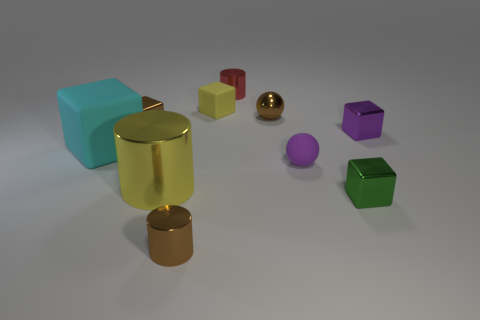Is there a tiny rubber object that is in front of the tiny brown metallic object left of the large yellow metal cylinder?
Offer a very short reply. Yes. How many things are tiny metal cubes that are left of the tiny purple metal cube or tiny red blocks?
Offer a very short reply. 2. What material is the small block behind the brown cube behind the large yellow cylinder?
Provide a short and direct response. Rubber. Is the number of tiny green objects that are on the right side of the tiny green shiny cube the same as the number of cyan cubes right of the tiny purple shiny object?
Your answer should be compact. Yes. How many things are tiny brown objects to the left of the red cylinder or small metallic objects that are to the right of the small brown cylinder?
Provide a succinct answer. 6. What is the tiny thing that is behind the tiny green metal object and on the right side of the tiny purple rubber object made of?
Offer a very short reply. Metal. There is a metallic cylinder that is behind the metallic cube on the left side of the small shiny cylinder that is left of the yellow cube; how big is it?
Provide a succinct answer. Small. Is the number of small shiny blocks greater than the number of objects?
Offer a terse response. No. Is the material of the small cylinder in front of the green shiny block the same as the purple cube?
Make the answer very short. Yes. Are there fewer small purple balls than large cyan rubber spheres?
Provide a short and direct response. No. 